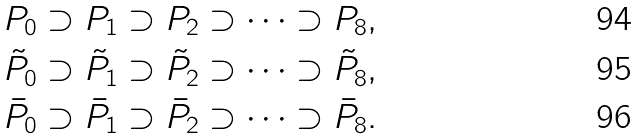Convert formula to latex. <formula><loc_0><loc_0><loc_500><loc_500>P _ { 0 } \supset P _ { 1 } \supset P _ { 2 } \supset \dots \supset P _ { 8 } , \\ \tilde { P } _ { 0 } \supset \tilde { P } _ { 1 } \supset \tilde { P } _ { 2 } \supset \dots \supset \tilde { P } _ { 8 } , \\ \bar { P } _ { 0 } \supset \bar { P } _ { 1 } \supset \bar { P } _ { 2 } \supset \dots \supset \bar { P } _ { 8 } .</formula> 